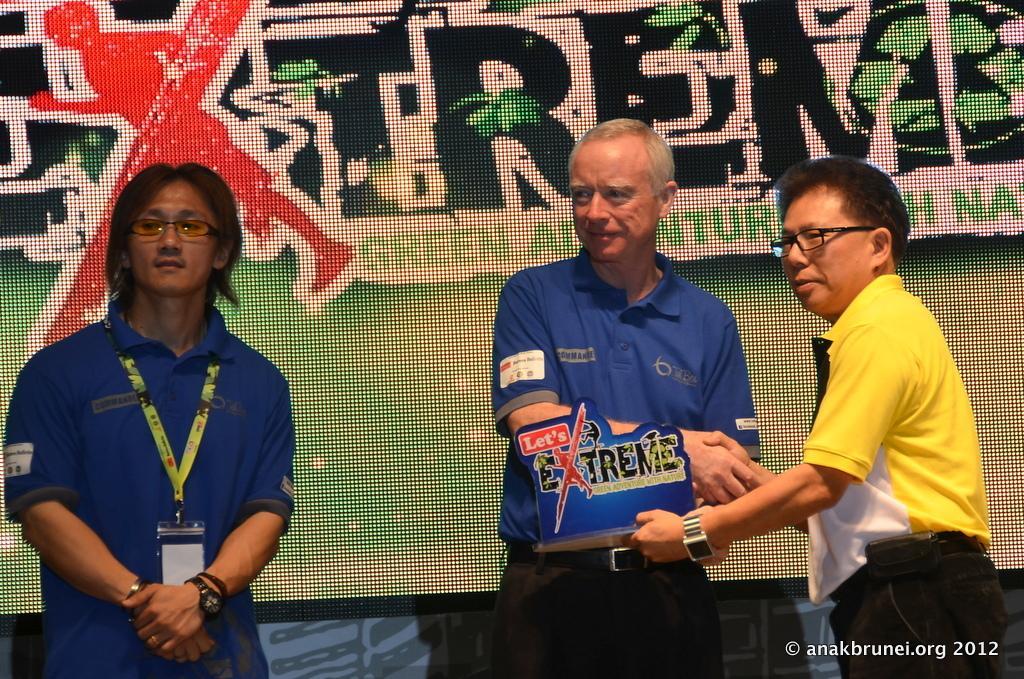Describe this image in one or two sentences. In this image there is a person wearing spectacles. He is standing. Right side there is a person wearing spectacles. He is shaking the hand with the person wearing a blue top. Background there is a screen having some text displayed on it. 